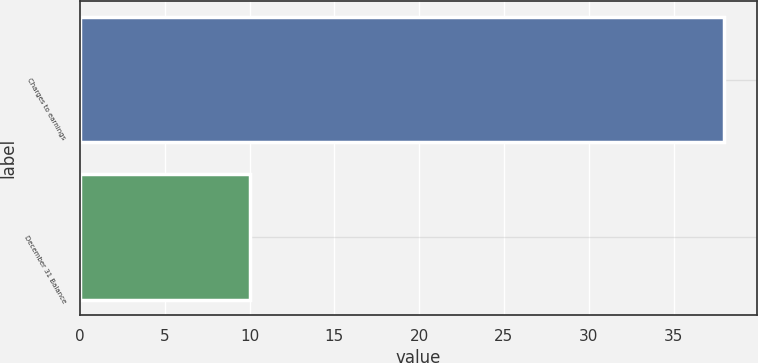Convert chart. <chart><loc_0><loc_0><loc_500><loc_500><bar_chart><fcel>Charges to earnings<fcel>December 31 Balance<nl><fcel>38<fcel>10<nl></chart> 